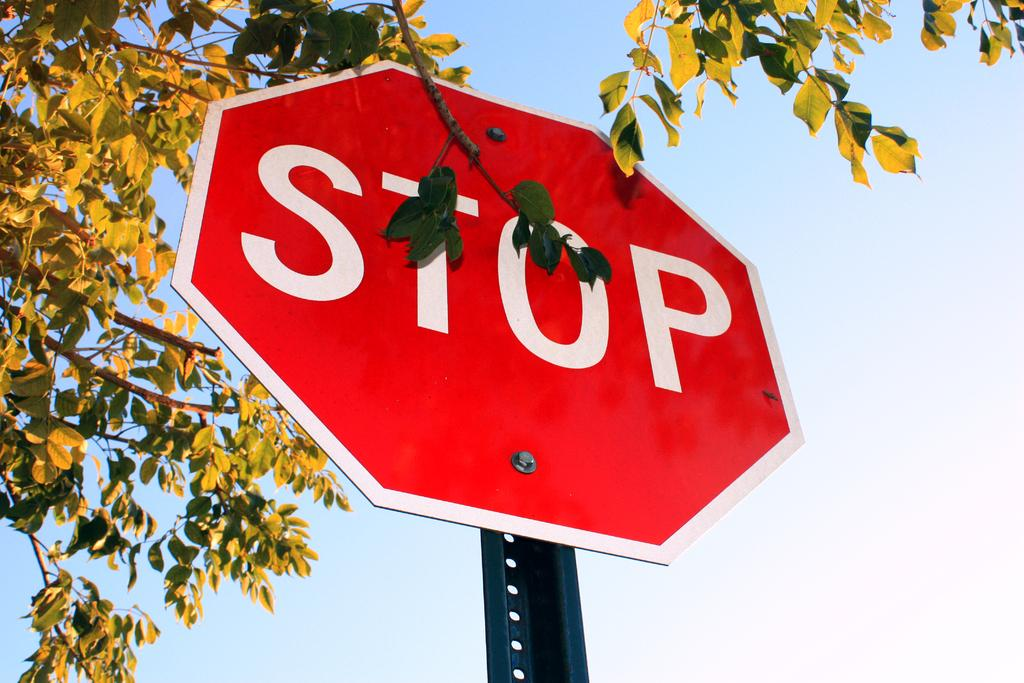Provide a one-sentence caption for the provided image. A bright red sign has the word "STOP" on it in white letters. 